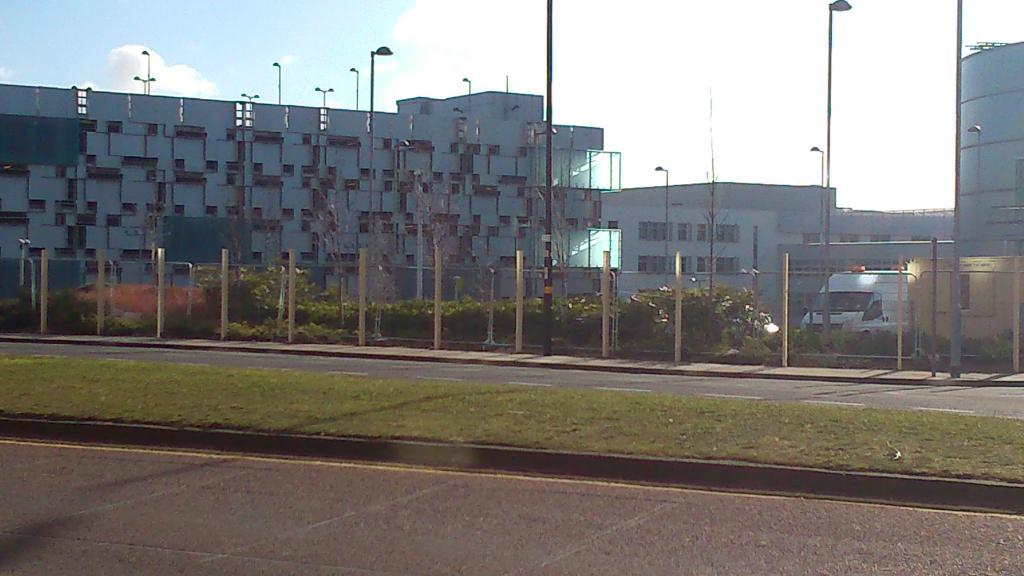What type of structures can be seen in the image? There are buildings in the image. What natural elements are present in the image? There are trees in the image. What are the vertical structures in the image? There are poles in the image. What are the illuminated objects in the image? There are lights in the image. What is the horizontal feature at the bottom of the image? There is a road at the bottom of the image. How many times does the fog appear in the image? There is no fog present in the image. Can you describe the kicking motion of the person in the image? There is no person or kicking motion present in the image. 